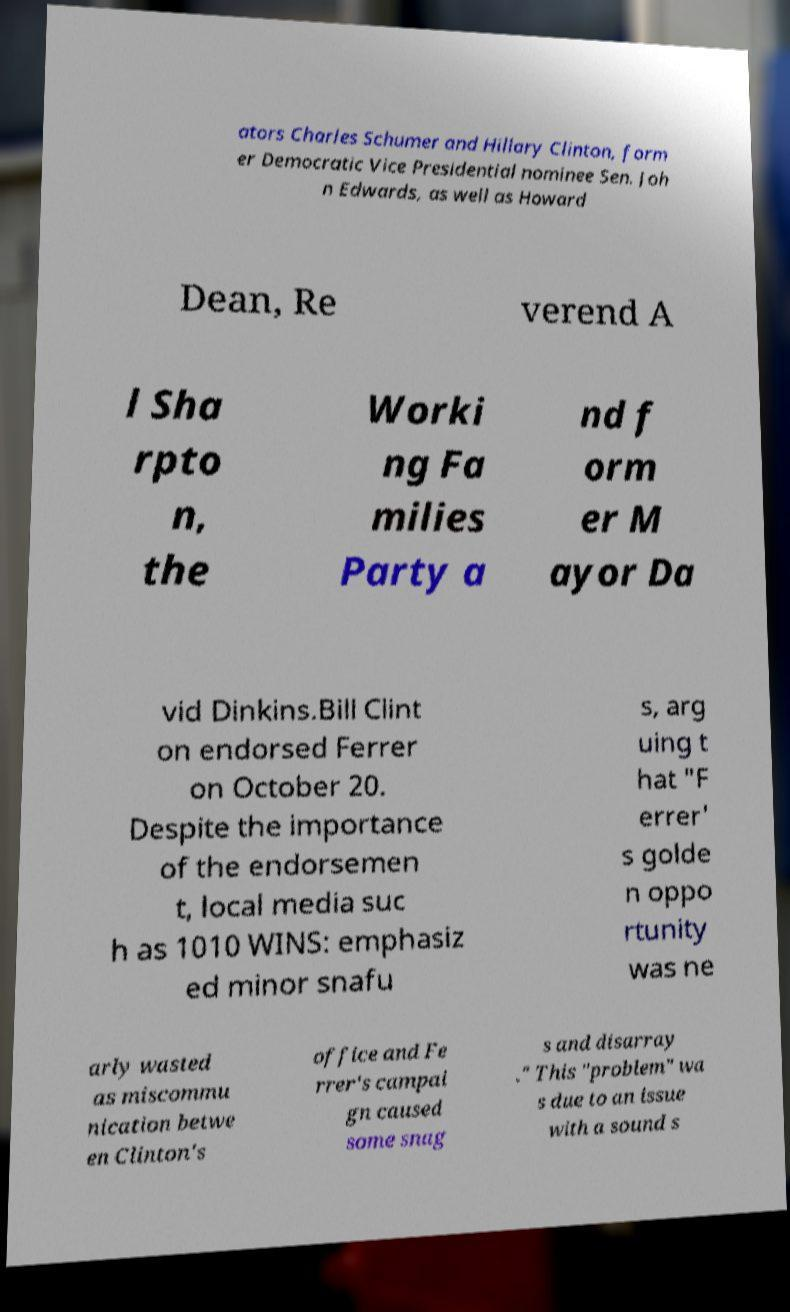Could you extract and type out the text from this image? ators Charles Schumer and Hillary Clinton, form er Democratic Vice Presidential nominee Sen. Joh n Edwards, as well as Howard Dean, Re verend A l Sha rpto n, the Worki ng Fa milies Party a nd f orm er M ayor Da vid Dinkins.Bill Clint on endorsed Ferrer on October 20. Despite the importance of the endorsemen t, local media suc h as 1010 WINS: emphasiz ed minor snafu s, arg uing t hat "F errer' s golde n oppo rtunity was ne arly wasted as miscommu nication betwe en Clinton's office and Fe rrer's campai gn caused some snag s and disarray ." This "problem" wa s due to an issue with a sound s 